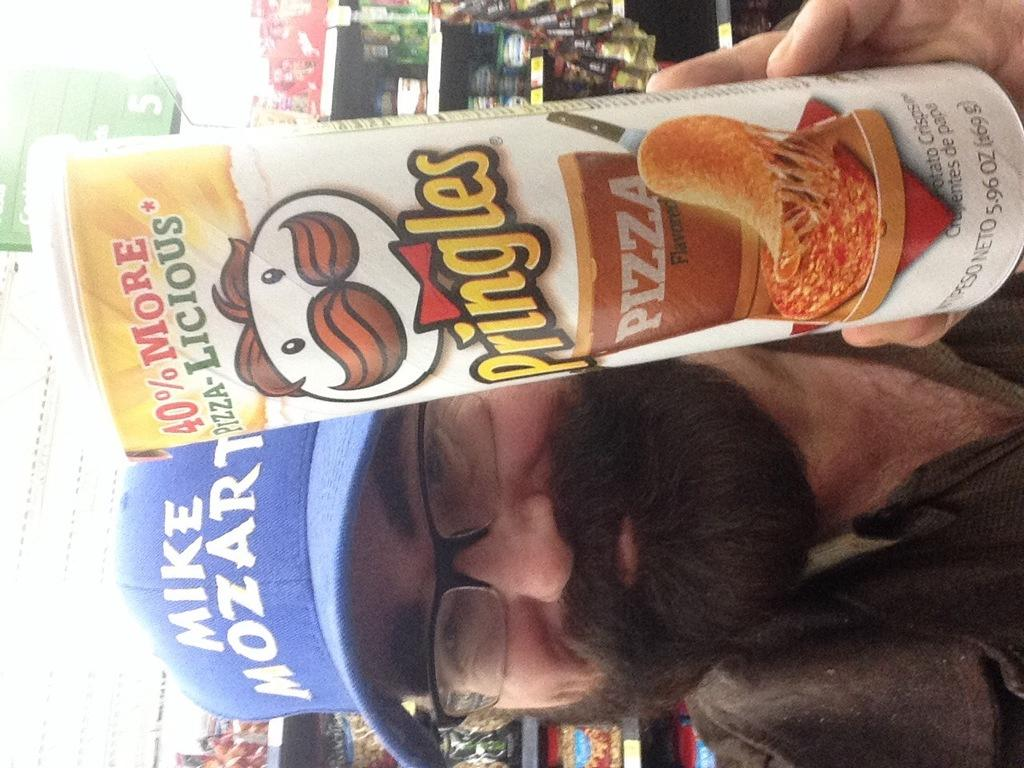What can be seen in the image? There is a person in the image. What is the person doing in the image? The person is holding an object. What else can be observed in the background of the image? There are objects on a rack in the background of the image. What type of gate can be seen in the image? There is no gate present in the image. Is there a cellar visible in the image? There is no cellar visible in the image. 